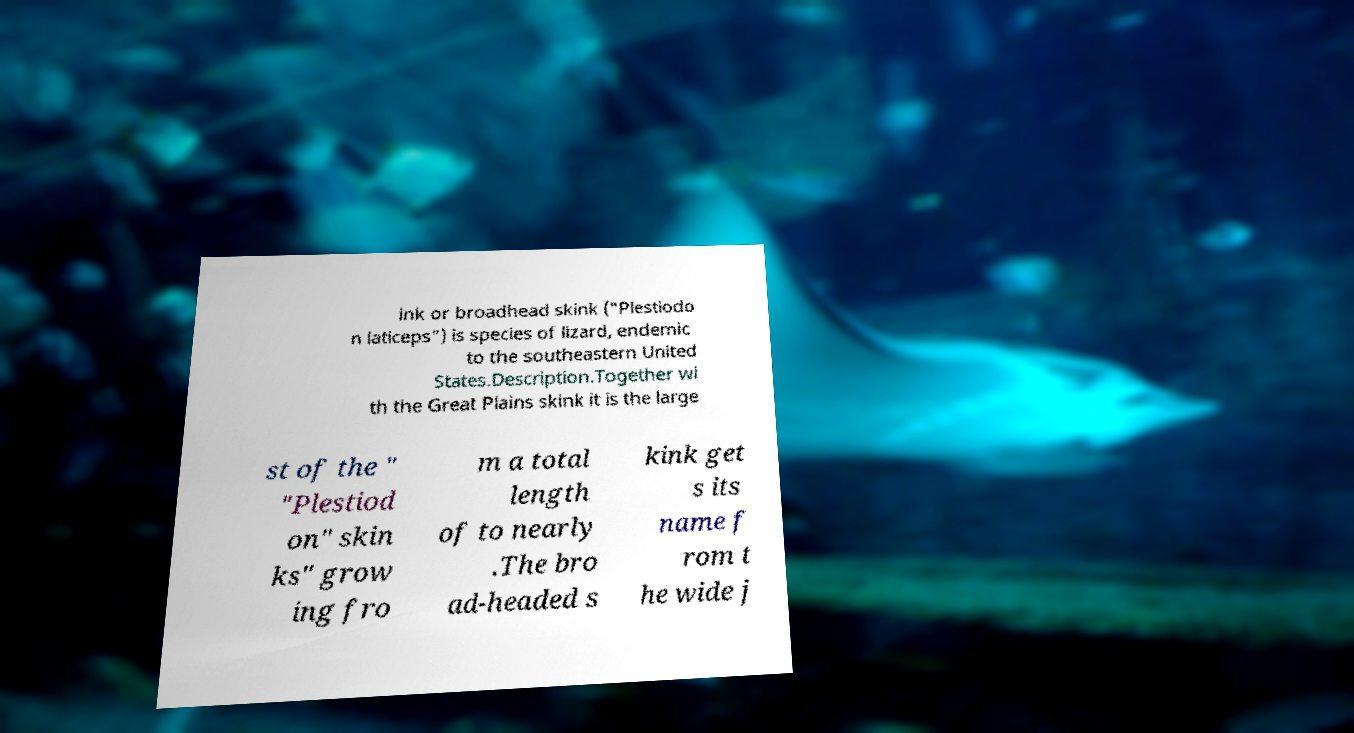Please read and relay the text visible in this image. What does it say? ink or broadhead skink ("Plestiodo n laticeps") is species of lizard, endemic to the southeastern United States.Description.Together wi th the Great Plains skink it is the large st of the " "Plestiod on" skin ks" grow ing fro m a total length of to nearly .The bro ad-headed s kink get s its name f rom t he wide j 